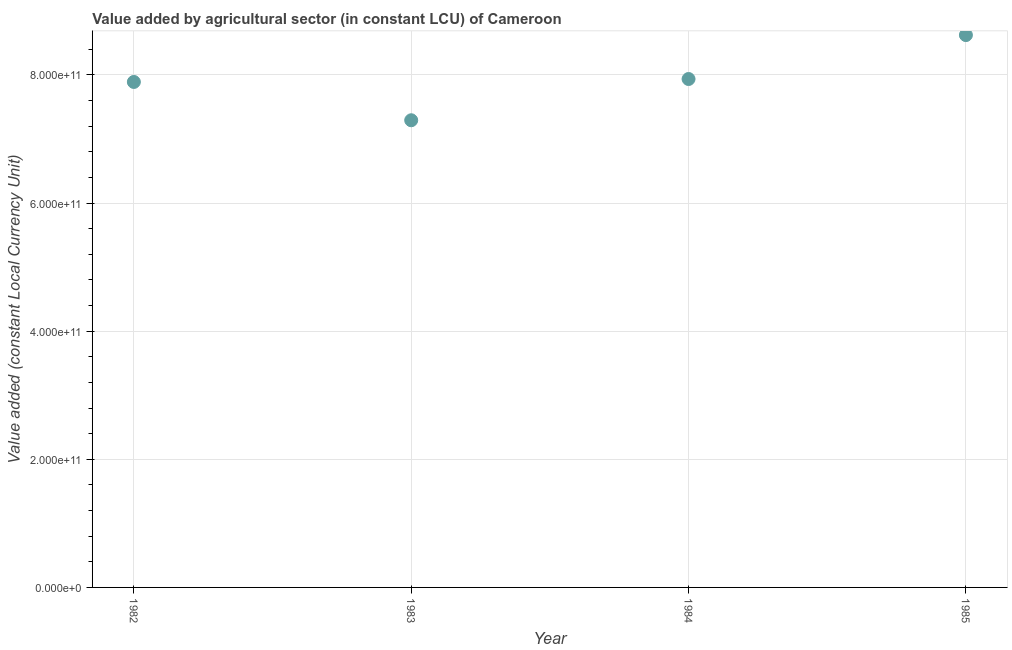What is the value added by agriculture sector in 1983?
Offer a very short reply. 7.29e+11. Across all years, what is the maximum value added by agriculture sector?
Make the answer very short. 8.62e+11. Across all years, what is the minimum value added by agriculture sector?
Give a very brief answer. 7.29e+11. In which year was the value added by agriculture sector minimum?
Offer a very short reply. 1983. What is the sum of the value added by agriculture sector?
Make the answer very short. 3.17e+12. What is the difference between the value added by agriculture sector in 1982 and 1984?
Give a very brief answer. -4.61e+09. What is the average value added by agriculture sector per year?
Ensure brevity in your answer.  7.94e+11. What is the median value added by agriculture sector?
Keep it short and to the point. 7.91e+11. Do a majority of the years between 1984 and 1983 (inclusive) have value added by agriculture sector greater than 80000000000 LCU?
Your response must be concise. No. What is the ratio of the value added by agriculture sector in 1982 to that in 1983?
Give a very brief answer. 1.08. Is the value added by agriculture sector in 1982 less than that in 1984?
Offer a terse response. Yes. What is the difference between the highest and the second highest value added by agriculture sector?
Keep it short and to the point. 6.86e+1. What is the difference between the highest and the lowest value added by agriculture sector?
Offer a terse response. 1.33e+11. Does the value added by agriculture sector monotonically increase over the years?
Make the answer very short. No. How many dotlines are there?
Provide a short and direct response. 1. What is the difference between two consecutive major ticks on the Y-axis?
Keep it short and to the point. 2.00e+11. Are the values on the major ticks of Y-axis written in scientific E-notation?
Offer a terse response. Yes. Does the graph contain any zero values?
Ensure brevity in your answer.  No. What is the title of the graph?
Give a very brief answer. Value added by agricultural sector (in constant LCU) of Cameroon. What is the label or title of the Y-axis?
Give a very brief answer. Value added (constant Local Currency Unit). What is the Value added (constant Local Currency Unit) in 1982?
Your answer should be very brief. 7.89e+11. What is the Value added (constant Local Currency Unit) in 1983?
Offer a very short reply. 7.29e+11. What is the Value added (constant Local Currency Unit) in 1984?
Give a very brief answer. 7.94e+11. What is the Value added (constant Local Currency Unit) in 1985?
Your response must be concise. 8.62e+11. What is the difference between the Value added (constant Local Currency Unit) in 1982 and 1983?
Offer a very short reply. 5.98e+1. What is the difference between the Value added (constant Local Currency Unit) in 1982 and 1984?
Give a very brief answer. -4.61e+09. What is the difference between the Value added (constant Local Currency Unit) in 1982 and 1985?
Your answer should be very brief. -7.32e+1. What is the difference between the Value added (constant Local Currency Unit) in 1983 and 1984?
Provide a succinct answer. -6.44e+1. What is the difference between the Value added (constant Local Currency Unit) in 1983 and 1985?
Your answer should be very brief. -1.33e+11. What is the difference between the Value added (constant Local Currency Unit) in 1984 and 1985?
Give a very brief answer. -6.86e+1. What is the ratio of the Value added (constant Local Currency Unit) in 1982 to that in 1983?
Provide a short and direct response. 1.08. What is the ratio of the Value added (constant Local Currency Unit) in 1982 to that in 1985?
Keep it short and to the point. 0.92. What is the ratio of the Value added (constant Local Currency Unit) in 1983 to that in 1984?
Offer a very short reply. 0.92. What is the ratio of the Value added (constant Local Currency Unit) in 1983 to that in 1985?
Provide a short and direct response. 0.85. What is the ratio of the Value added (constant Local Currency Unit) in 1984 to that in 1985?
Give a very brief answer. 0.92. 